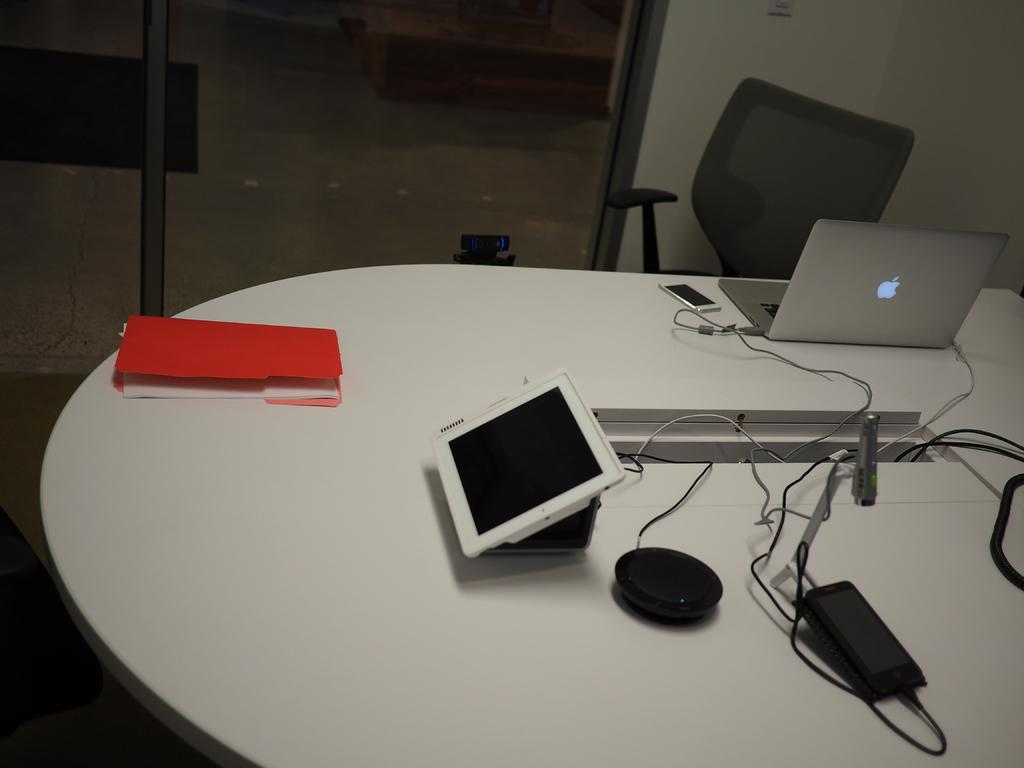What is the color of the table in the image? The table in the image is white. What electronic device is on the table? A laptop is present on the table. What type of document or paperwork is on the table? There is a file on the table. What other objects are on the table besides the laptop and file? Other objects are on the table, but their specific details are not mentioned in the facts. What type of seating is in the image? There is a chair in the image. What is the color of the wall in the image? The wall is white in color. What type of door is in the image? There is a glass door in the image. What is the weather like outside the glass door in the image? The facts provided do not mention any information about the weather, so it cannot be determined from the image. Is there a man sitting on the chair in the image? There is no mention of a man or any person in the image, so it cannot be determined from the facts. 